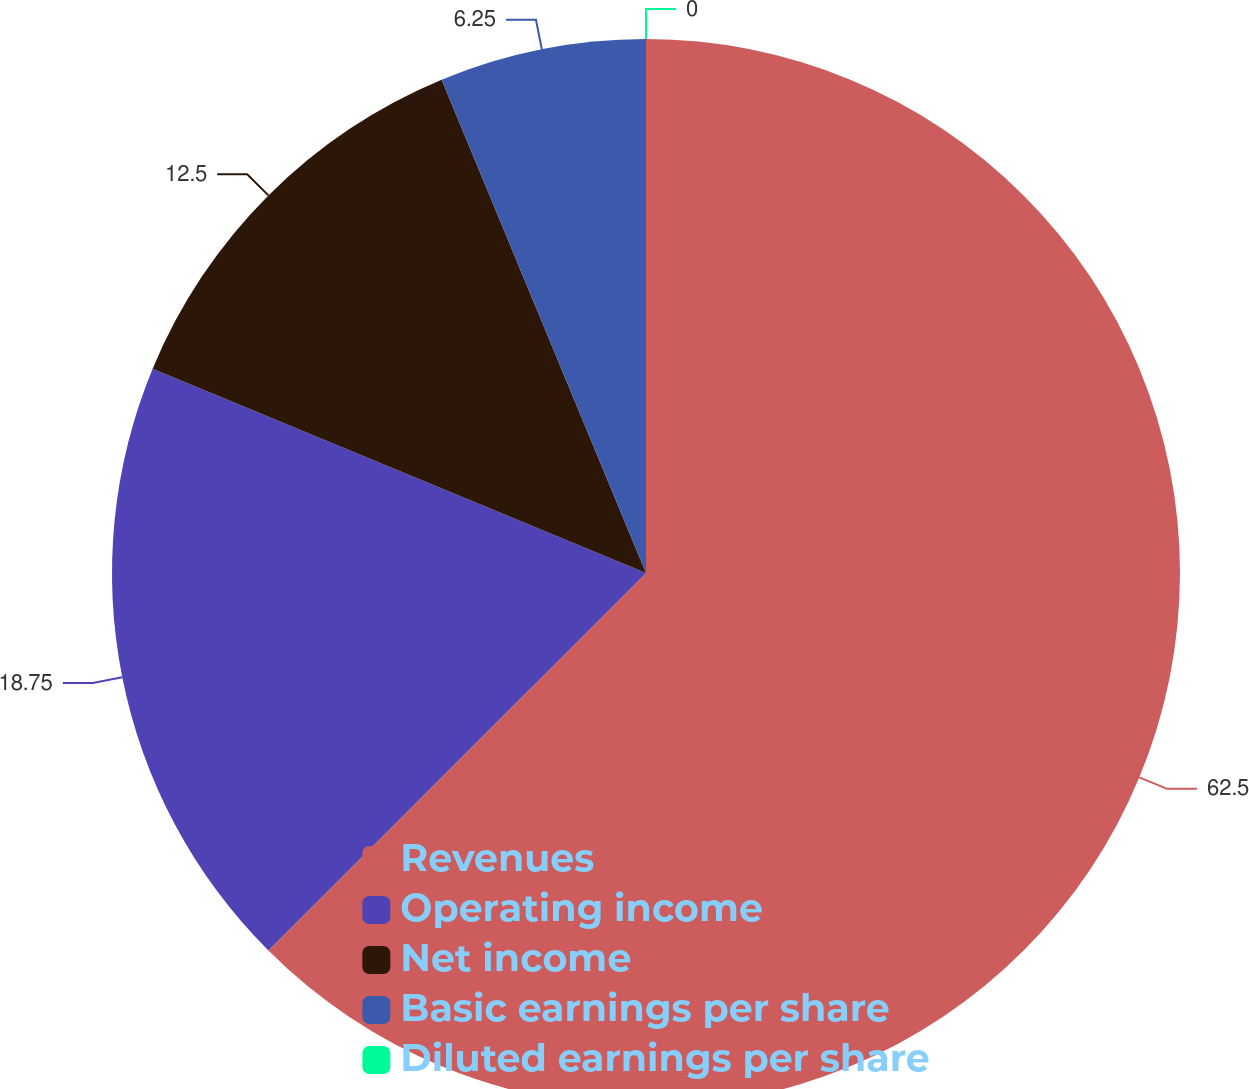Convert chart. <chart><loc_0><loc_0><loc_500><loc_500><pie_chart><fcel>Revenues<fcel>Operating income<fcel>Net income<fcel>Basic earnings per share<fcel>Diluted earnings per share<nl><fcel>62.5%<fcel>18.75%<fcel>12.5%<fcel>6.25%<fcel>0.0%<nl></chart> 